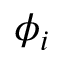Convert formula to latex. <formula><loc_0><loc_0><loc_500><loc_500>\phi _ { i }</formula> 